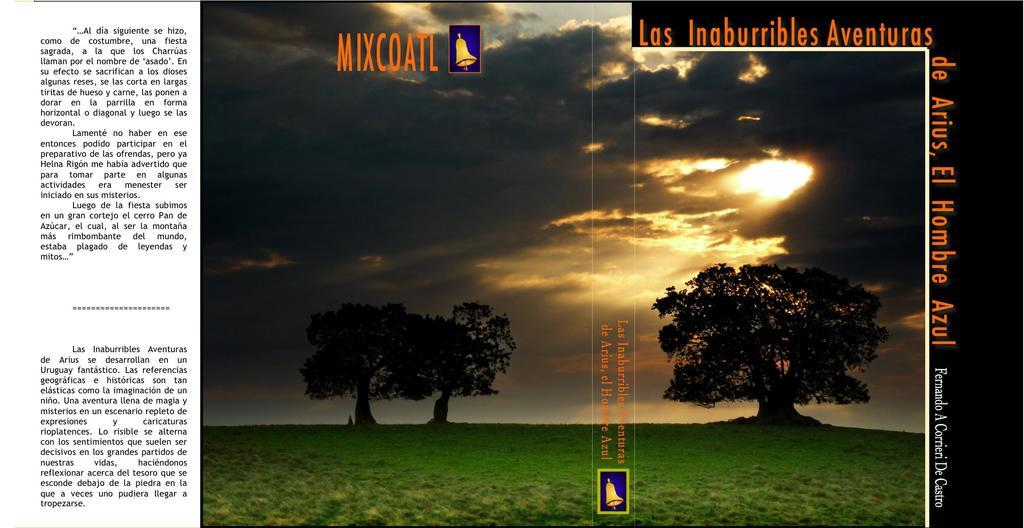What is featured on the poster in the image? There is a poster with text and images in the image. Can you describe the object near a tree? Unfortunately, the facts provided do not give enough information to describe the object near a tree. How many trees are visible in the image? There are three trees in the image. What type of vegetation is present on the ground? Grass is present on the ground. What is the condition of the sky in the image? The sky is visible in the background and appears to be cloudy. What type of wristwatch can be seen on the poster? There is no wristwatch present on the poster; it features text and images. Can you tell me how many balls are visible in the image? There are no balls visible in the image. 